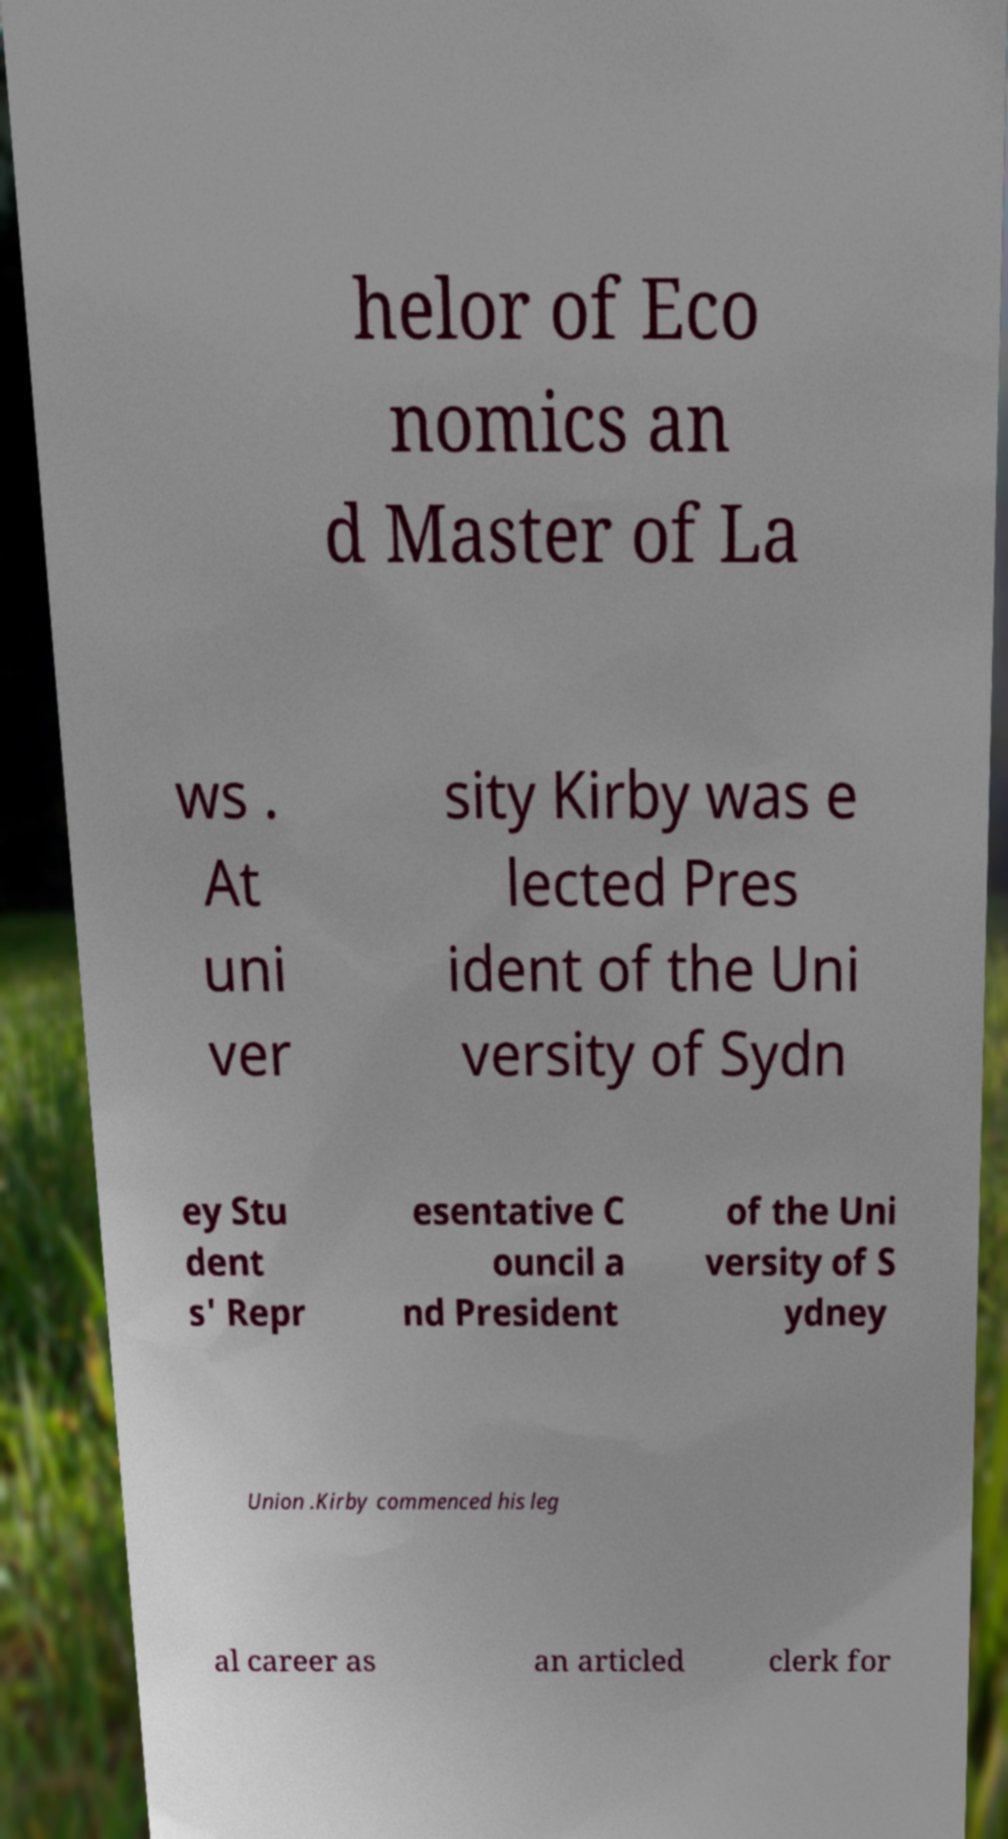There's text embedded in this image that I need extracted. Can you transcribe it verbatim? helor of Eco nomics an d Master of La ws . At uni ver sity Kirby was e lected Pres ident of the Uni versity of Sydn ey Stu dent s' Repr esentative C ouncil a nd President of the Uni versity of S ydney Union .Kirby commenced his leg al career as an articled clerk for 